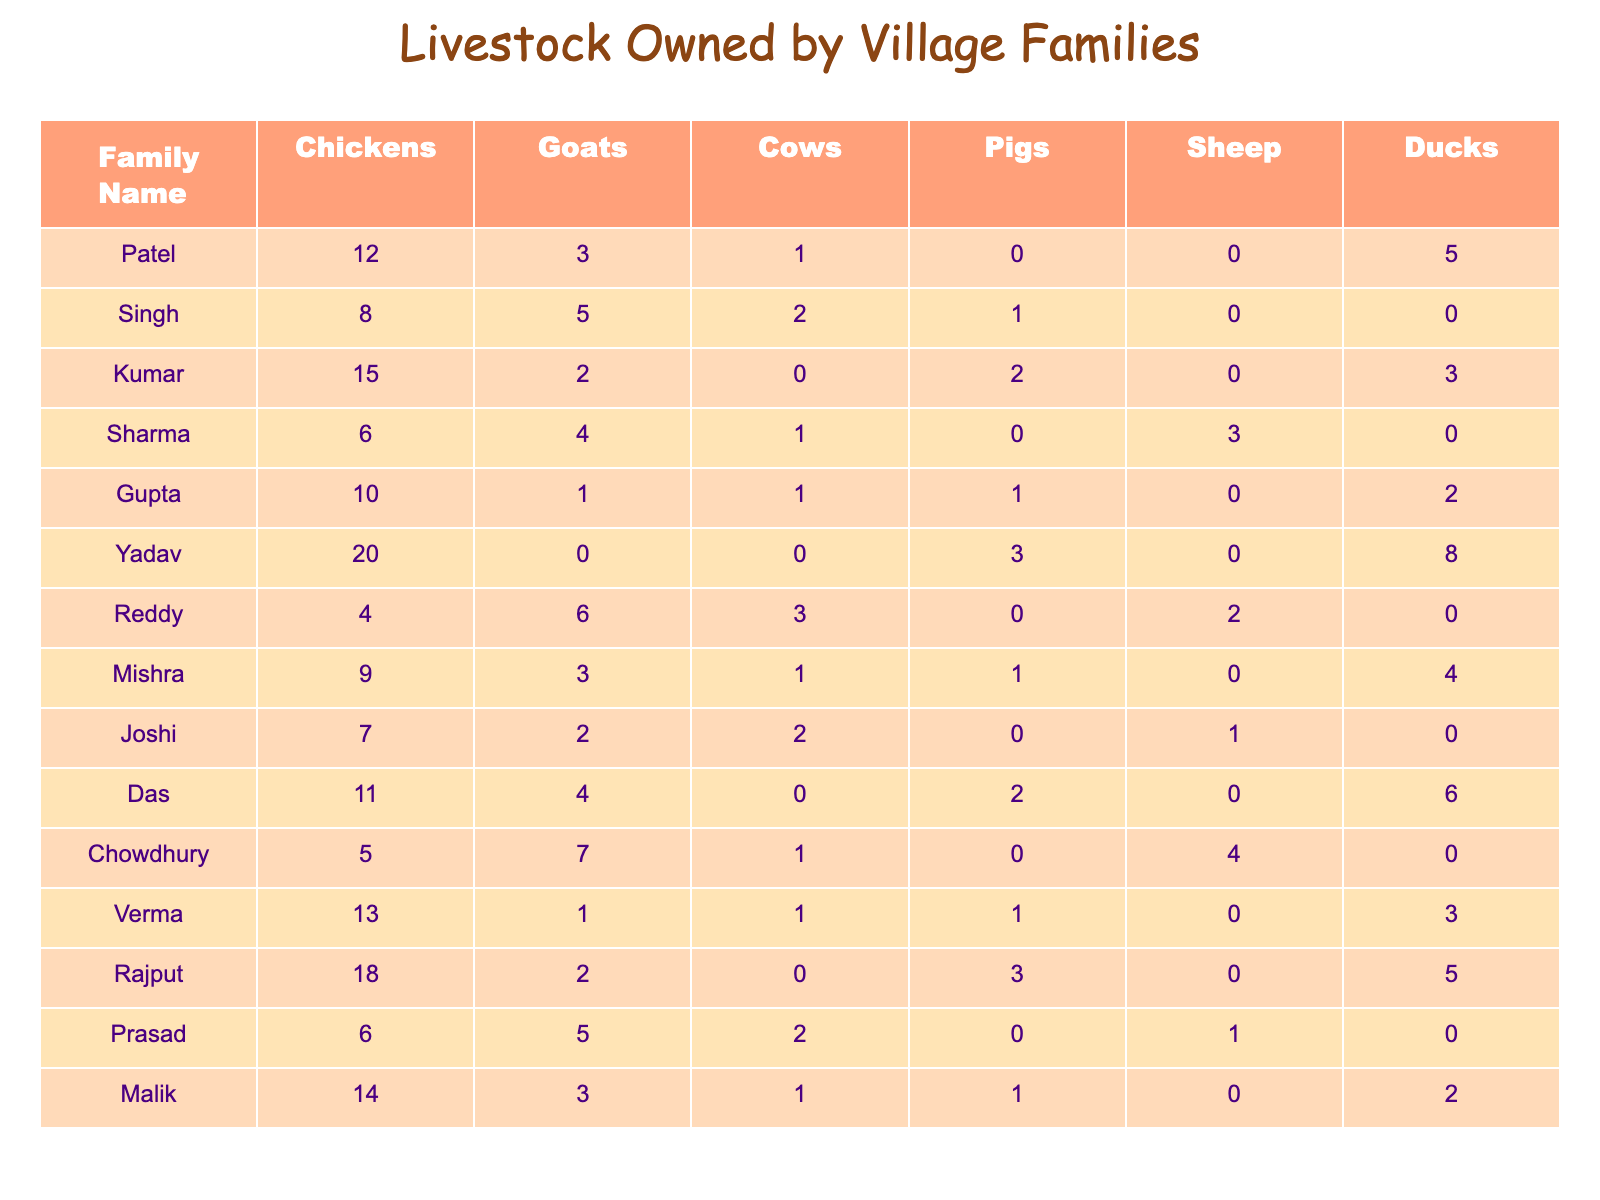What is the total number of goats owned by the families in the village? To find the total number of goats, we add the number of goats owned by each family: 3 + 5 + 2 + 4 + 1 + 0 + 6 + 3 + 2 + 4 + 7 + 1 + 2 + 5 + 3 = 43.
Answer: 43 Which family owns the highest number of chickens? By looking at the number of chickens owned by each family, we see that Yadav has the most with 20 chickens.
Answer: Yadav How many families have pigs? We count the families that have more than 0 pigs: Kumar (2), Singh (1), Das (2), and Rajput (3). There are a total of 4 families with pigs.
Answer: 4 What is the average number of cows owned by the families? We sum the number of cows owned by all families: 1 + 2 + 0 + 1 + 1 + 0 + 3 + 1 + 2 + 0 + 1 + 0 + 0 + 2 + 1 = 14. There are 15 families, so the average is 14 divided by 15, which equals approximately 0.93.
Answer: 0.93 Does any family own more sheep than ducks? We compare the number of sheep and ducks for each family. Only Sharma (3 sheep, 0 ducks) and Chowdhury (4 sheep, 0 ducks) own more sheep than ducks. Therefore, there are families that own more sheep than ducks.
Answer: Yes What is the difference in the number of ducks between the family with the most ducks and the family with the least ducks? Yadav has the most ducks with 8, and several families have 0 ducks. Thus, the difference is 8 - 0 = 8.
Answer: 8 Which family owns the fewest livestock in total? We calculate the total livestock for each family. The total for each family shows that Gupta has the fewest with 4 (1 cow + 1 pig + 2 ducks).
Answer: Gupta If we combine the number of goats and sheep owned by all families, what is the total? We add the goats (43) and sheep (8) owned by all families together: 43 + 8 = 51.
Answer: 51 How many families own cows and pigs? We check each family for cows and pigs. Families that have both include Singh, Reddy, and Kumar, making it a total of 3 families.
Answer: 3 Is it true that the Patel family owns more ducks than any other family owns pigs? Patel has 5 ducks, and looking at the number of pigs owned by the families, we find that the highest is 3 (Rajput). Since 5 > 3, the statement is true.
Answer: Yes 